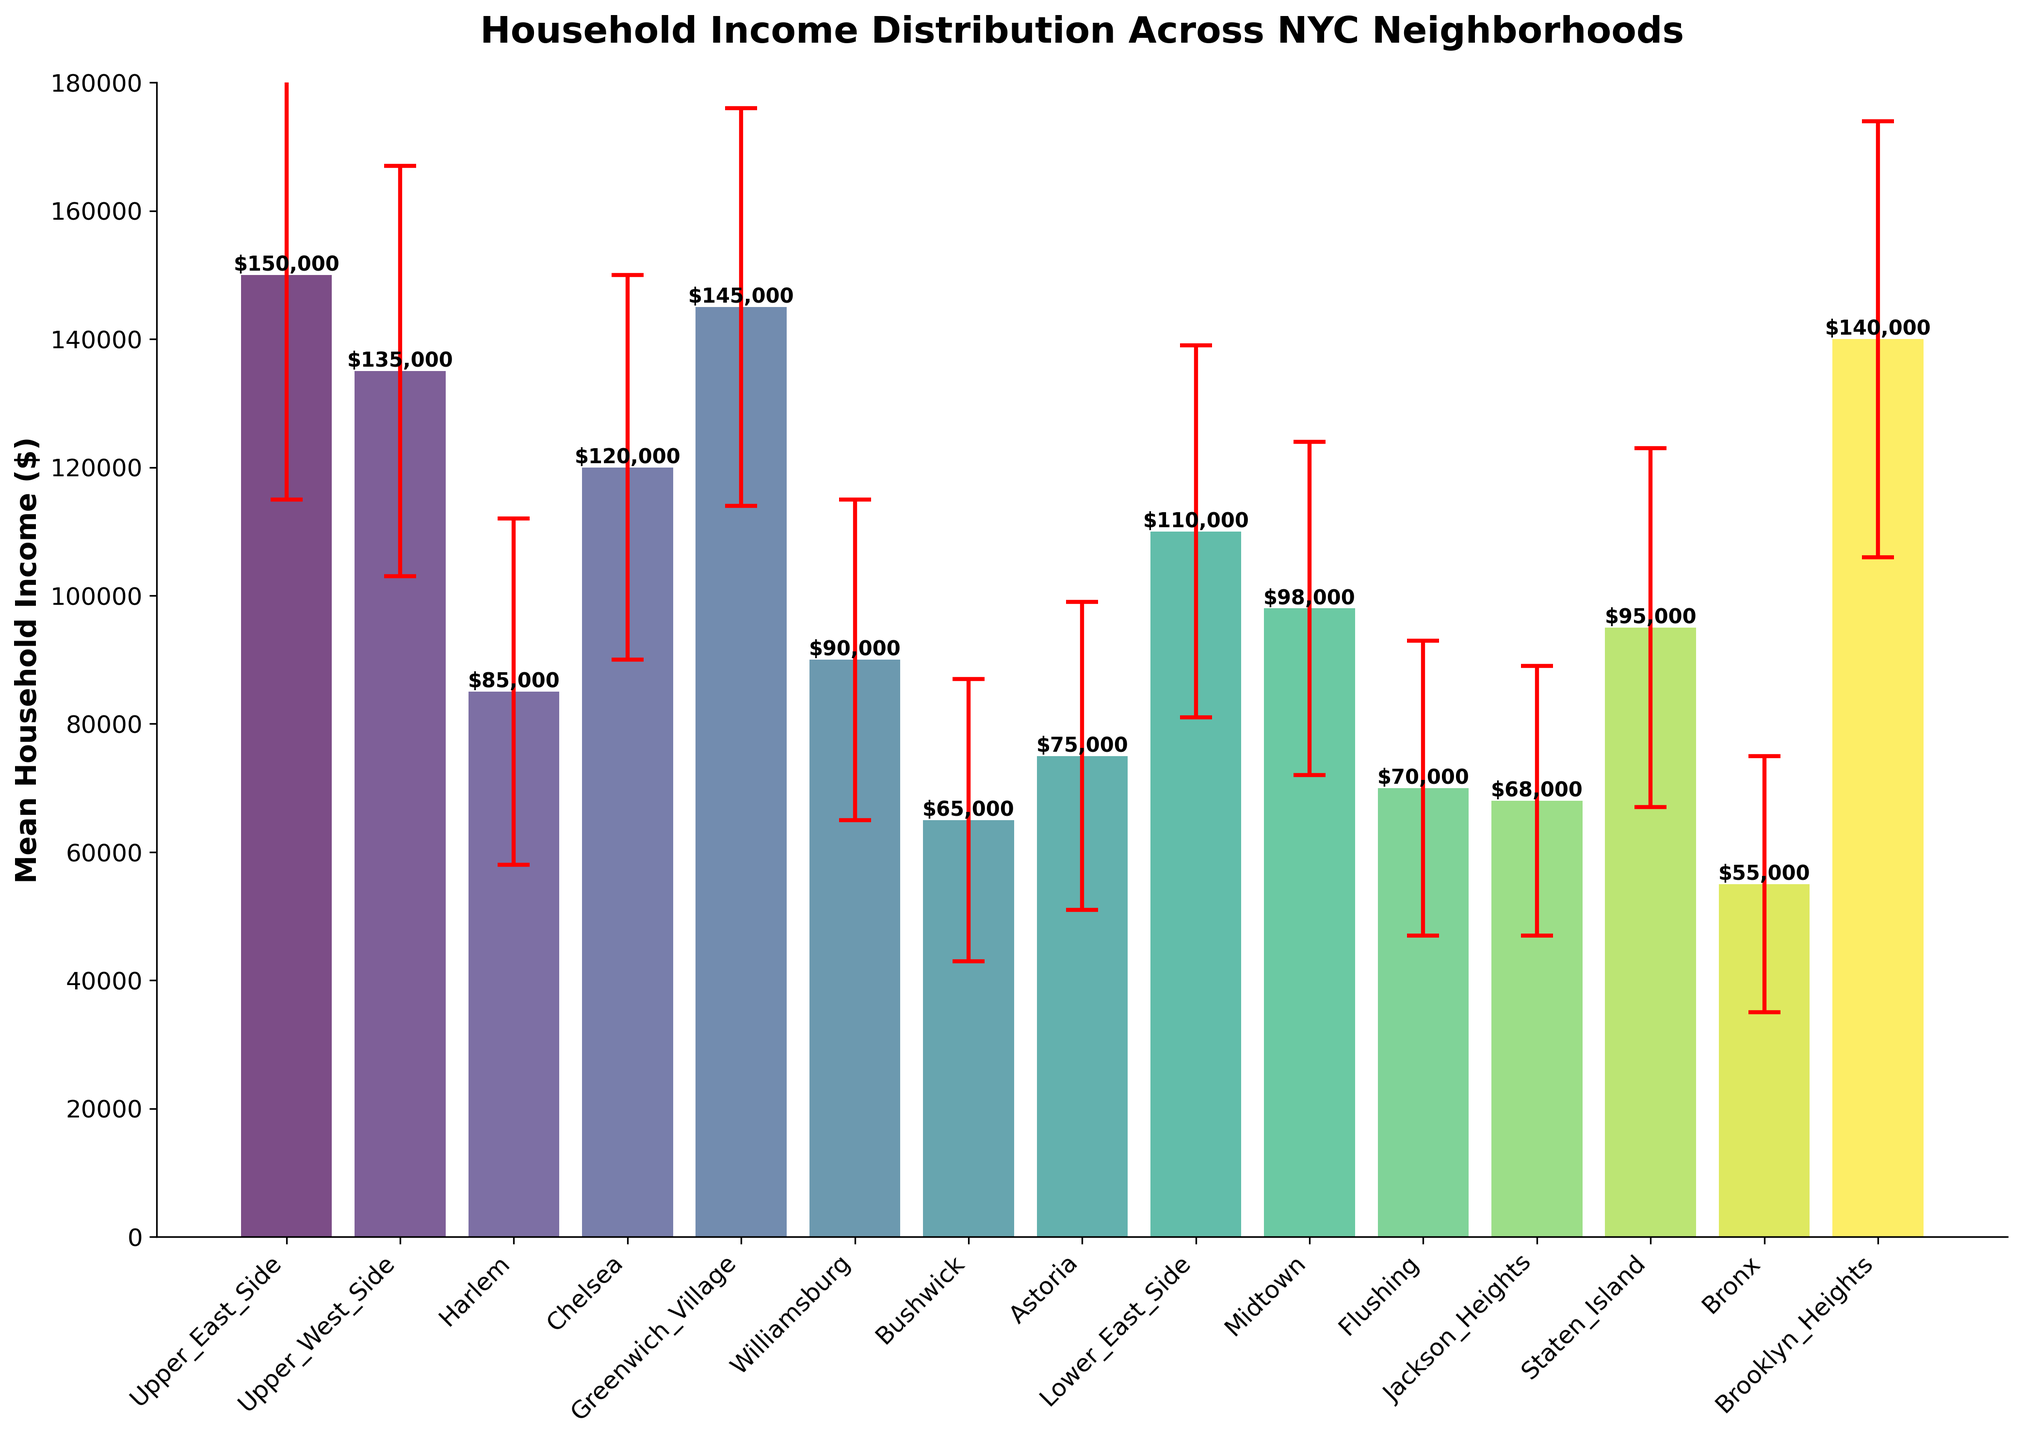What is the bar color representing the Upper West Side? To determine the color of the bar representing the Upper West Side, locate this neighborhood on the x-axis and observe the corresponding bar. The colors from the `viridis` colormap transition from purple to yellow as you move from left to right. Therefore, the Upper West Side bar color would be a shade of purple or blue.
Answer: Blue/Purple Which neighborhood has the highest mean household income? Identify the tallest bar in the plot and look at the x-axis label corresponding to this bar. The Upper East Side has the highest bar, indicating the highest mean household income.
Answer: Upper East Side Which neighborhood has the lowest mean household income? Identify the shortest bar in the plot and look at the x-axis label corresponding to this bar. The Bronx has the shortest bar, indicating the lowest mean household income.
Answer: Bronx What is the approximate mean household income for Chelsea? Locate the bar for Chelsea on the x-axis and identify the height of this bar, which is around $120,000.
Answer: $120,000 How do the income values for Williamsburg and Bushwick compare? Identify the heights of the bars for Williamsburg and Bushwick. Williamsburg has a value around $90,000, and Bushwick has a value around $65,000. So, Williamsburg's income is higher than Bushwick’s.
Answer: Williamsburg has higher income than Bushwick Which two neighborhoods have the closest mean household incomes? To find the two neighborhoods with the closest mean household incomes, look at the heights of all the bars and identify the pairs that are nearly the same. Greenwich Village ($145,000) and Upper East Side ($150,000) are very close, with a difference of $5,000.
Answer: Upper East Side and Greenwich Village What are the standard deviations used for error bars for Harlem and Bushwick? Observe the size of the error bars for Harlem and Bushwick. Harlem's error bar indicates a standard deviation of $27,000, while Bushwick's indicates $22,000.
Answer: $27,000 for Harlem and $22,000 for Bushwick How does the mean household income of Midtown compare with the average of Williamsburg and Bushwick? First, identify the mean household incomes: Midtown ($98,000), Williamsburg ($90,000), and Bushwick ($65,000). Calculate the average of Williamsburg and Bushwick: ($90,000 + $65,000) / 2 = $77,500. Midtown's income ($98,000) is higher than this average ($77,500).
Answer: Midtown's income is higher Which neighborhood has the most uncertainty in its mean household income? The neighborhood with the largest standard deviation value (length of the error bar) represents the most uncertainty. The Upper East Side has the largest error bar, indicating the most uncertainty.
Answer: Upper East Side 